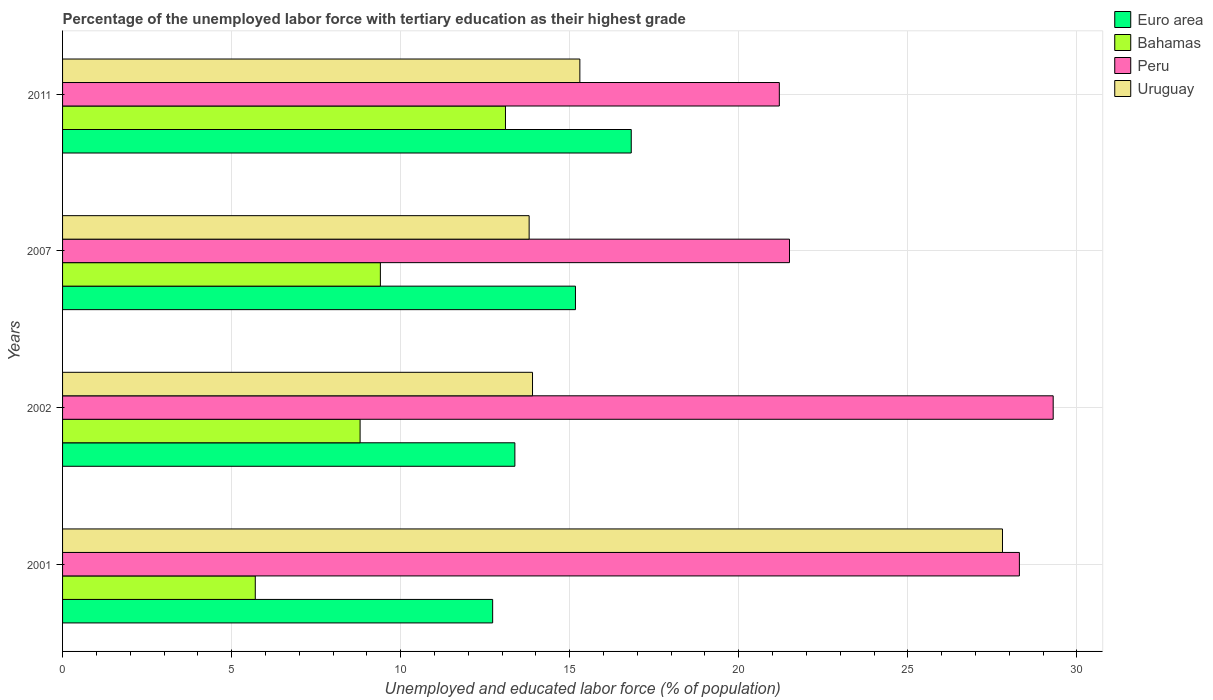Are the number of bars per tick equal to the number of legend labels?
Provide a short and direct response. Yes. Are the number of bars on each tick of the Y-axis equal?
Offer a terse response. Yes. How many bars are there on the 4th tick from the top?
Your answer should be compact. 4. In how many cases, is the number of bars for a given year not equal to the number of legend labels?
Ensure brevity in your answer.  0. What is the percentage of the unemployed labor force with tertiary education in Euro area in 2011?
Keep it short and to the point. 16.82. Across all years, what is the maximum percentage of the unemployed labor force with tertiary education in Uruguay?
Your answer should be very brief. 27.8. Across all years, what is the minimum percentage of the unemployed labor force with tertiary education in Peru?
Offer a very short reply. 21.2. In which year was the percentage of the unemployed labor force with tertiary education in Bahamas maximum?
Your answer should be compact. 2011. What is the total percentage of the unemployed labor force with tertiary education in Peru in the graph?
Keep it short and to the point. 100.3. What is the difference between the percentage of the unemployed labor force with tertiary education in Peru in 2001 and that in 2011?
Offer a terse response. 7.1. What is the difference between the percentage of the unemployed labor force with tertiary education in Euro area in 2011 and the percentage of the unemployed labor force with tertiary education in Peru in 2002?
Make the answer very short. -12.48. What is the average percentage of the unemployed labor force with tertiary education in Uruguay per year?
Provide a succinct answer. 17.7. In the year 2011, what is the difference between the percentage of the unemployed labor force with tertiary education in Euro area and percentage of the unemployed labor force with tertiary education in Peru?
Offer a very short reply. -4.38. In how many years, is the percentage of the unemployed labor force with tertiary education in Uruguay greater than 8 %?
Provide a succinct answer. 4. What is the ratio of the percentage of the unemployed labor force with tertiary education in Bahamas in 2002 to that in 2011?
Your answer should be compact. 0.67. What is the difference between the highest and the lowest percentage of the unemployed labor force with tertiary education in Peru?
Your answer should be very brief. 8.1. In how many years, is the percentage of the unemployed labor force with tertiary education in Euro area greater than the average percentage of the unemployed labor force with tertiary education in Euro area taken over all years?
Your answer should be compact. 2. What does the 4th bar from the top in 2011 represents?
Your response must be concise. Euro area. What does the 3rd bar from the bottom in 2002 represents?
Ensure brevity in your answer.  Peru. How many bars are there?
Ensure brevity in your answer.  16. Are all the bars in the graph horizontal?
Your answer should be very brief. Yes. How many years are there in the graph?
Your answer should be compact. 4. What is the difference between two consecutive major ticks on the X-axis?
Keep it short and to the point. 5. Are the values on the major ticks of X-axis written in scientific E-notation?
Ensure brevity in your answer.  No. Does the graph contain any zero values?
Your answer should be compact. No. Does the graph contain grids?
Make the answer very short. Yes. How are the legend labels stacked?
Your answer should be very brief. Vertical. What is the title of the graph?
Give a very brief answer. Percentage of the unemployed labor force with tertiary education as their highest grade. What is the label or title of the X-axis?
Your answer should be compact. Unemployed and educated labor force (% of population). What is the Unemployed and educated labor force (% of population) of Euro area in 2001?
Give a very brief answer. 12.72. What is the Unemployed and educated labor force (% of population) in Bahamas in 2001?
Keep it short and to the point. 5.7. What is the Unemployed and educated labor force (% of population) in Peru in 2001?
Make the answer very short. 28.3. What is the Unemployed and educated labor force (% of population) in Uruguay in 2001?
Give a very brief answer. 27.8. What is the Unemployed and educated labor force (% of population) of Euro area in 2002?
Offer a very short reply. 13.38. What is the Unemployed and educated labor force (% of population) of Bahamas in 2002?
Provide a succinct answer. 8.8. What is the Unemployed and educated labor force (% of population) of Peru in 2002?
Your response must be concise. 29.3. What is the Unemployed and educated labor force (% of population) of Uruguay in 2002?
Give a very brief answer. 13.9. What is the Unemployed and educated labor force (% of population) in Euro area in 2007?
Ensure brevity in your answer.  15.17. What is the Unemployed and educated labor force (% of population) of Bahamas in 2007?
Give a very brief answer. 9.4. What is the Unemployed and educated labor force (% of population) of Peru in 2007?
Your response must be concise. 21.5. What is the Unemployed and educated labor force (% of population) in Uruguay in 2007?
Make the answer very short. 13.8. What is the Unemployed and educated labor force (% of population) of Euro area in 2011?
Give a very brief answer. 16.82. What is the Unemployed and educated labor force (% of population) in Bahamas in 2011?
Ensure brevity in your answer.  13.1. What is the Unemployed and educated labor force (% of population) of Peru in 2011?
Offer a very short reply. 21.2. What is the Unemployed and educated labor force (% of population) in Uruguay in 2011?
Your response must be concise. 15.3. Across all years, what is the maximum Unemployed and educated labor force (% of population) in Euro area?
Offer a very short reply. 16.82. Across all years, what is the maximum Unemployed and educated labor force (% of population) of Bahamas?
Keep it short and to the point. 13.1. Across all years, what is the maximum Unemployed and educated labor force (% of population) of Peru?
Provide a short and direct response. 29.3. Across all years, what is the maximum Unemployed and educated labor force (% of population) of Uruguay?
Offer a very short reply. 27.8. Across all years, what is the minimum Unemployed and educated labor force (% of population) of Euro area?
Keep it short and to the point. 12.72. Across all years, what is the minimum Unemployed and educated labor force (% of population) in Bahamas?
Provide a succinct answer. 5.7. Across all years, what is the minimum Unemployed and educated labor force (% of population) of Peru?
Your answer should be compact. 21.2. Across all years, what is the minimum Unemployed and educated labor force (% of population) of Uruguay?
Give a very brief answer. 13.8. What is the total Unemployed and educated labor force (% of population) of Euro area in the graph?
Offer a terse response. 58.09. What is the total Unemployed and educated labor force (% of population) of Peru in the graph?
Your response must be concise. 100.3. What is the total Unemployed and educated labor force (% of population) in Uruguay in the graph?
Provide a succinct answer. 70.8. What is the difference between the Unemployed and educated labor force (% of population) in Euro area in 2001 and that in 2002?
Offer a terse response. -0.66. What is the difference between the Unemployed and educated labor force (% of population) of Euro area in 2001 and that in 2007?
Make the answer very short. -2.45. What is the difference between the Unemployed and educated labor force (% of population) in Bahamas in 2001 and that in 2007?
Keep it short and to the point. -3.7. What is the difference between the Unemployed and educated labor force (% of population) of Peru in 2001 and that in 2007?
Keep it short and to the point. 6.8. What is the difference between the Unemployed and educated labor force (% of population) in Uruguay in 2001 and that in 2007?
Keep it short and to the point. 14. What is the difference between the Unemployed and educated labor force (% of population) of Euro area in 2001 and that in 2011?
Offer a terse response. -4.1. What is the difference between the Unemployed and educated labor force (% of population) of Peru in 2001 and that in 2011?
Keep it short and to the point. 7.1. What is the difference between the Unemployed and educated labor force (% of population) in Uruguay in 2001 and that in 2011?
Ensure brevity in your answer.  12.5. What is the difference between the Unemployed and educated labor force (% of population) of Euro area in 2002 and that in 2007?
Keep it short and to the point. -1.79. What is the difference between the Unemployed and educated labor force (% of population) of Bahamas in 2002 and that in 2007?
Provide a succinct answer. -0.6. What is the difference between the Unemployed and educated labor force (% of population) in Peru in 2002 and that in 2007?
Ensure brevity in your answer.  7.8. What is the difference between the Unemployed and educated labor force (% of population) in Euro area in 2002 and that in 2011?
Your answer should be very brief. -3.44. What is the difference between the Unemployed and educated labor force (% of population) of Bahamas in 2002 and that in 2011?
Keep it short and to the point. -4.3. What is the difference between the Unemployed and educated labor force (% of population) in Uruguay in 2002 and that in 2011?
Offer a terse response. -1.4. What is the difference between the Unemployed and educated labor force (% of population) in Euro area in 2007 and that in 2011?
Your answer should be compact. -1.65. What is the difference between the Unemployed and educated labor force (% of population) of Peru in 2007 and that in 2011?
Offer a terse response. 0.3. What is the difference between the Unemployed and educated labor force (% of population) in Uruguay in 2007 and that in 2011?
Provide a succinct answer. -1.5. What is the difference between the Unemployed and educated labor force (% of population) in Euro area in 2001 and the Unemployed and educated labor force (% of population) in Bahamas in 2002?
Keep it short and to the point. 3.92. What is the difference between the Unemployed and educated labor force (% of population) of Euro area in 2001 and the Unemployed and educated labor force (% of population) of Peru in 2002?
Your response must be concise. -16.58. What is the difference between the Unemployed and educated labor force (% of population) of Euro area in 2001 and the Unemployed and educated labor force (% of population) of Uruguay in 2002?
Provide a succinct answer. -1.18. What is the difference between the Unemployed and educated labor force (% of population) of Bahamas in 2001 and the Unemployed and educated labor force (% of population) of Peru in 2002?
Offer a terse response. -23.6. What is the difference between the Unemployed and educated labor force (% of population) in Bahamas in 2001 and the Unemployed and educated labor force (% of population) in Uruguay in 2002?
Your answer should be compact. -8.2. What is the difference between the Unemployed and educated labor force (% of population) of Peru in 2001 and the Unemployed and educated labor force (% of population) of Uruguay in 2002?
Give a very brief answer. 14.4. What is the difference between the Unemployed and educated labor force (% of population) of Euro area in 2001 and the Unemployed and educated labor force (% of population) of Bahamas in 2007?
Provide a short and direct response. 3.32. What is the difference between the Unemployed and educated labor force (% of population) of Euro area in 2001 and the Unemployed and educated labor force (% of population) of Peru in 2007?
Keep it short and to the point. -8.78. What is the difference between the Unemployed and educated labor force (% of population) of Euro area in 2001 and the Unemployed and educated labor force (% of population) of Uruguay in 2007?
Your answer should be compact. -1.08. What is the difference between the Unemployed and educated labor force (% of population) of Bahamas in 2001 and the Unemployed and educated labor force (% of population) of Peru in 2007?
Offer a terse response. -15.8. What is the difference between the Unemployed and educated labor force (% of population) of Peru in 2001 and the Unemployed and educated labor force (% of population) of Uruguay in 2007?
Your answer should be compact. 14.5. What is the difference between the Unemployed and educated labor force (% of population) of Euro area in 2001 and the Unemployed and educated labor force (% of population) of Bahamas in 2011?
Provide a short and direct response. -0.38. What is the difference between the Unemployed and educated labor force (% of population) of Euro area in 2001 and the Unemployed and educated labor force (% of population) of Peru in 2011?
Your response must be concise. -8.48. What is the difference between the Unemployed and educated labor force (% of population) in Euro area in 2001 and the Unemployed and educated labor force (% of population) in Uruguay in 2011?
Your answer should be very brief. -2.58. What is the difference between the Unemployed and educated labor force (% of population) of Bahamas in 2001 and the Unemployed and educated labor force (% of population) of Peru in 2011?
Provide a succinct answer. -15.5. What is the difference between the Unemployed and educated labor force (% of population) in Bahamas in 2001 and the Unemployed and educated labor force (% of population) in Uruguay in 2011?
Offer a terse response. -9.6. What is the difference between the Unemployed and educated labor force (% of population) of Euro area in 2002 and the Unemployed and educated labor force (% of population) of Bahamas in 2007?
Offer a very short reply. 3.98. What is the difference between the Unemployed and educated labor force (% of population) in Euro area in 2002 and the Unemployed and educated labor force (% of population) in Peru in 2007?
Give a very brief answer. -8.12. What is the difference between the Unemployed and educated labor force (% of population) of Euro area in 2002 and the Unemployed and educated labor force (% of population) of Uruguay in 2007?
Provide a short and direct response. -0.42. What is the difference between the Unemployed and educated labor force (% of population) of Bahamas in 2002 and the Unemployed and educated labor force (% of population) of Uruguay in 2007?
Make the answer very short. -5. What is the difference between the Unemployed and educated labor force (% of population) of Euro area in 2002 and the Unemployed and educated labor force (% of population) of Bahamas in 2011?
Provide a succinct answer. 0.28. What is the difference between the Unemployed and educated labor force (% of population) of Euro area in 2002 and the Unemployed and educated labor force (% of population) of Peru in 2011?
Ensure brevity in your answer.  -7.82. What is the difference between the Unemployed and educated labor force (% of population) in Euro area in 2002 and the Unemployed and educated labor force (% of population) in Uruguay in 2011?
Provide a short and direct response. -1.92. What is the difference between the Unemployed and educated labor force (% of population) of Euro area in 2007 and the Unemployed and educated labor force (% of population) of Bahamas in 2011?
Keep it short and to the point. 2.07. What is the difference between the Unemployed and educated labor force (% of population) in Euro area in 2007 and the Unemployed and educated labor force (% of population) in Peru in 2011?
Offer a very short reply. -6.03. What is the difference between the Unemployed and educated labor force (% of population) of Euro area in 2007 and the Unemployed and educated labor force (% of population) of Uruguay in 2011?
Your answer should be very brief. -0.13. What is the difference between the Unemployed and educated labor force (% of population) of Peru in 2007 and the Unemployed and educated labor force (% of population) of Uruguay in 2011?
Provide a short and direct response. 6.2. What is the average Unemployed and educated labor force (% of population) of Euro area per year?
Your response must be concise. 14.52. What is the average Unemployed and educated labor force (% of population) in Bahamas per year?
Your answer should be compact. 9.25. What is the average Unemployed and educated labor force (% of population) of Peru per year?
Give a very brief answer. 25.07. In the year 2001, what is the difference between the Unemployed and educated labor force (% of population) of Euro area and Unemployed and educated labor force (% of population) of Bahamas?
Make the answer very short. 7.02. In the year 2001, what is the difference between the Unemployed and educated labor force (% of population) in Euro area and Unemployed and educated labor force (% of population) in Peru?
Your response must be concise. -15.58. In the year 2001, what is the difference between the Unemployed and educated labor force (% of population) in Euro area and Unemployed and educated labor force (% of population) in Uruguay?
Provide a succinct answer. -15.08. In the year 2001, what is the difference between the Unemployed and educated labor force (% of population) of Bahamas and Unemployed and educated labor force (% of population) of Peru?
Your answer should be compact. -22.6. In the year 2001, what is the difference between the Unemployed and educated labor force (% of population) of Bahamas and Unemployed and educated labor force (% of population) of Uruguay?
Your response must be concise. -22.1. In the year 2002, what is the difference between the Unemployed and educated labor force (% of population) in Euro area and Unemployed and educated labor force (% of population) in Bahamas?
Ensure brevity in your answer.  4.58. In the year 2002, what is the difference between the Unemployed and educated labor force (% of population) of Euro area and Unemployed and educated labor force (% of population) of Peru?
Offer a very short reply. -15.92. In the year 2002, what is the difference between the Unemployed and educated labor force (% of population) of Euro area and Unemployed and educated labor force (% of population) of Uruguay?
Ensure brevity in your answer.  -0.52. In the year 2002, what is the difference between the Unemployed and educated labor force (% of population) of Bahamas and Unemployed and educated labor force (% of population) of Peru?
Offer a terse response. -20.5. In the year 2002, what is the difference between the Unemployed and educated labor force (% of population) of Peru and Unemployed and educated labor force (% of population) of Uruguay?
Give a very brief answer. 15.4. In the year 2007, what is the difference between the Unemployed and educated labor force (% of population) in Euro area and Unemployed and educated labor force (% of population) in Bahamas?
Provide a succinct answer. 5.77. In the year 2007, what is the difference between the Unemployed and educated labor force (% of population) of Euro area and Unemployed and educated labor force (% of population) of Peru?
Offer a terse response. -6.33. In the year 2007, what is the difference between the Unemployed and educated labor force (% of population) in Euro area and Unemployed and educated labor force (% of population) in Uruguay?
Keep it short and to the point. 1.37. In the year 2007, what is the difference between the Unemployed and educated labor force (% of population) in Bahamas and Unemployed and educated labor force (% of population) in Peru?
Your answer should be compact. -12.1. In the year 2007, what is the difference between the Unemployed and educated labor force (% of population) of Peru and Unemployed and educated labor force (% of population) of Uruguay?
Your answer should be very brief. 7.7. In the year 2011, what is the difference between the Unemployed and educated labor force (% of population) of Euro area and Unemployed and educated labor force (% of population) of Bahamas?
Offer a very short reply. 3.72. In the year 2011, what is the difference between the Unemployed and educated labor force (% of population) in Euro area and Unemployed and educated labor force (% of population) in Peru?
Your answer should be very brief. -4.38. In the year 2011, what is the difference between the Unemployed and educated labor force (% of population) of Euro area and Unemployed and educated labor force (% of population) of Uruguay?
Make the answer very short. 1.52. In the year 2011, what is the difference between the Unemployed and educated labor force (% of population) of Bahamas and Unemployed and educated labor force (% of population) of Peru?
Offer a very short reply. -8.1. In the year 2011, what is the difference between the Unemployed and educated labor force (% of population) in Bahamas and Unemployed and educated labor force (% of population) in Uruguay?
Make the answer very short. -2.2. In the year 2011, what is the difference between the Unemployed and educated labor force (% of population) in Peru and Unemployed and educated labor force (% of population) in Uruguay?
Provide a short and direct response. 5.9. What is the ratio of the Unemployed and educated labor force (% of population) of Euro area in 2001 to that in 2002?
Offer a terse response. 0.95. What is the ratio of the Unemployed and educated labor force (% of population) in Bahamas in 2001 to that in 2002?
Keep it short and to the point. 0.65. What is the ratio of the Unemployed and educated labor force (% of population) of Peru in 2001 to that in 2002?
Give a very brief answer. 0.97. What is the ratio of the Unemployed and educated labor force (% of population) in Euro area in 2001 to that in 2007?
Provide a succinct answer. 0.84. What is the ratio of the Unemployed and educated labor force (% of population) of Bahamas in 2001 to that in 2007?
Offer a very short reply. 0.61. What is the ratio of the Unemployed and educated labor force (% of population) in Peru in 2001 to that in 2007?
Ensure brevity in your answer.  1.32. What is the ratio of the Unemployed and educated labor force (% of population) in Uruguay in 2001 to that in 2007?
Keep it short and to the point. 2.01. What is the ratio of the Unemployed and educated labor force (% of population) in Euro area in 2001 to that in 2011?
Make the answer very short. 0.76. What is the ratio of the Unemployed and educated labor force (% of population) in Bahamas in 2001 to that in 2011?
Offer a terse response. 0.44. What is the ratio of the Unemployed and educated labor force (% of population) in Peru in 2001 to that in 2011?
Your response must be concise. 1.33. What is the ratio of the Unemployed and educated labor force (% of population) of Uruguay in 2001 to that in 2011?
Your answer should be compact. 1.82. What is the ratio of the Unemployed and educated labor force (% of population) of Euro area in 2002 to that in 2007?
Provide a succinct answer. 0.88. What is the ratio of the Unemployed and educated labor force (% of population) of Bahamas in 2002 to that in 2007?
Your response must be concise. 0.94. What is the ratio of the Unemployed and educated labor force (% of population) in Peru in 2002 to that in 2007?
Keep it short and to the point. 1.36. What is the ratio of the Unemployed and educated labor force (% of population) in Uruguay in 2002 to that in 2007?
Make the answer very short. 1.01. What is the ratio of the Unemployed and educated labor force (% of population) of Euro area in 2002 to that in 2011?
Offer a terse response. 0.8. What is the ratio of the Unemployed and educated labor force (% of population) in Bahamas in 2002 to that in 2011?
Provide a short and direct response. 0.67. What is the ratio of the Unemployed and educated labor force (% of population) in Peru in 2002 to that in 2011?
Offer a terse response. 1.38. What is the ratio of the Unemployed and educated labor force (% of population) of Uruguay in 2002 to that in 2011?
Provide a succinct answer. 0.91. What is the ratio of the Unemployed and educated labor force (% of population) in Euro area in 2007 to that in 2011?
Provide a short and direct response. 0.9. What is the ratio of the Unemployed and educated labor force (% of population) in Bahamas in 2007 to that in 2011?
Provide a succinct answer. 0.72. What is the ratio of the Unemployed and educated labor force (% of population) in Peru in 2007 to that in 2011?
Make the answer very short. 1.01. What is the ratio of the Unemployed and educated labor force (% of population) of Uruguay in 2007 to that in 2011?
Provide a short and direct response. 0.9. What is the difference between the highest and the second highest Unemployed and educated labor force (% of population) of Euro area?
Provide a succinct answer. 1.65. What is the difference between the highest and the second highest Unemployed and educated labor force (% of population) of Bahamas?
Offer a terse response. 3.7. What is the difference between the highest and the lowest Unemployed and educated labor force (% of population) of Euro area?
Make the answer very short. 4.1. What is the difference between the highest and the lowest Unemployed and educated labor force (% of population) of Bahamas?
Give a very brief answer. 7.4. 